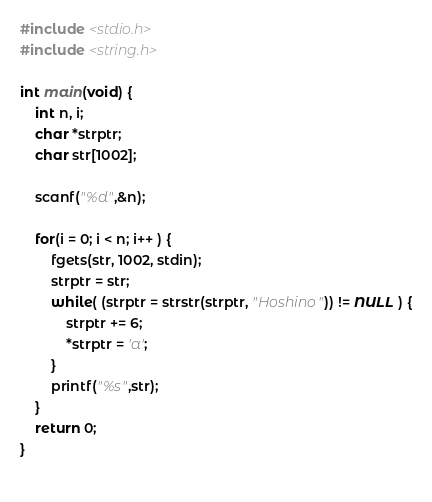Convert code to text. <code><loc_0><loc_0><loc_500><loc_500><_C_>#include <stdio.h>
#include <string.h>

int main(void) {
    int n, i;
    char *strptr;
    char str[1002];

    scanf("%d",&n);

    for(i = 0; i < n; i++ ) {
        fgets(str, 1002, stdin);
        strptr = str;
        while( (strptr = strstr(strptr, "Hoshino")) != NULL ) {
            strptr += 6;
            *strptr = 'a';
        }
        printf("%s",str);
    }
    return 0;
}
    </code> 